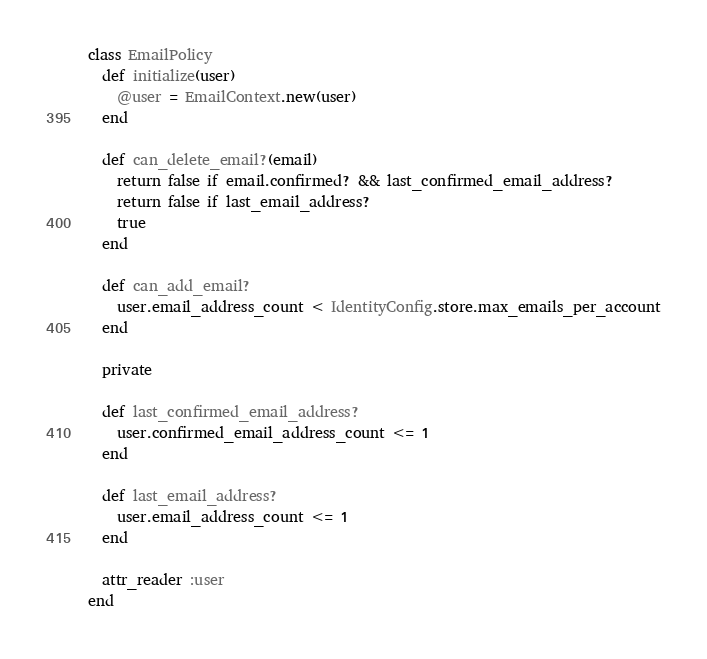Convert code to text. <code><loc_0><loc_0><loc_500><loc_500><_Ruby_>class EmailPolicy
  def initialize(user)
    @user = EmailContext.new(user)
  end

  def can_delete_email?(email)
    return false if email.confirmed? && last_confirmed_email_address?
    return false if last_email_address?
    true
  end

  def can_add_email?
    user.email_address_count < IdentityConfig.store.max_emails_per_account
  end

  private

  def last_confirmed_email_address?
    user.confirmed_email_address_count <= 1
  end

  def last_email_address?
    user.email_address_count <= 1
  end

  attr_reader :user
end
</code> 